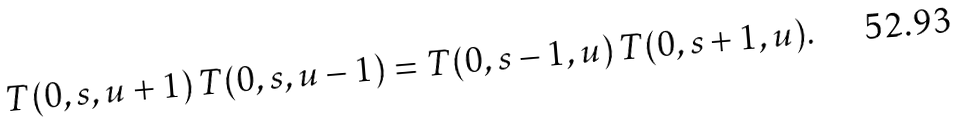Convert formula to latex. <formula><loc_0><loc_0><loc_500><loc_500>T ( 0 , s , u + 1 ) \, T ( 0 , s , u - 1 ) = T ( 0 , s - 1 , u ) \, T ( 0 , s + 1 , u ) .</formula> 